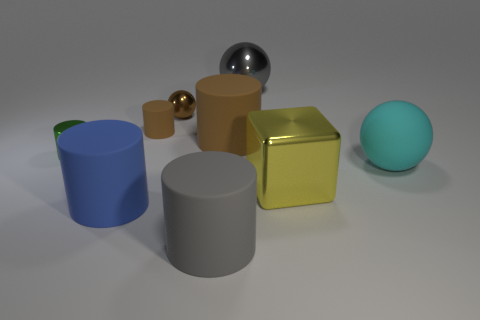Subtract all blue cylinders. How many cylinders are left? 4 Subtract 1 cylinders. How many cylinders are left? 4 Subtract all small green metal cylinders. How many cylinders are left? 4 Subtract all green cylinders. Subtract all cyan balls. How many cylinders are left? 4 Add 1 balls. How many objects exist? 10 Subtract all blocks. How many objects are left? 8 Add 2 large brown things. How many large brown things exist? 3 Subtract 0 brown cubes. How many objects are left? 9 Subtract all large brown rubber things. Subtract all brown shiny blocks. How many objects are left? 8 Add 9 gray shiny balls. How many gray shiny balls are left? 10 